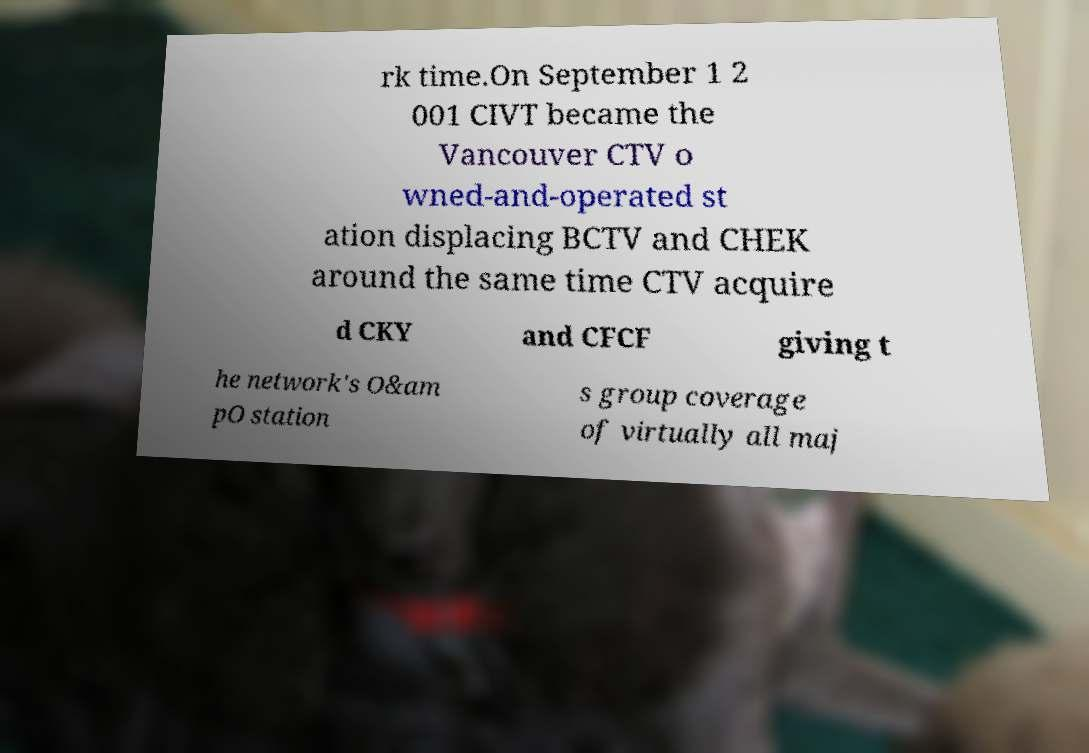Could you assist in decoding the text presented in this image and type it out clearly? rk time.On September 1 2 001 CIVT became the Vancouver CTV o wned-and-operated st ation displacing BCTV and CHEK around the same time CTV acquire d CKY and CFCF giving t he network's O&am pO station s group coverage of virtually all maj 